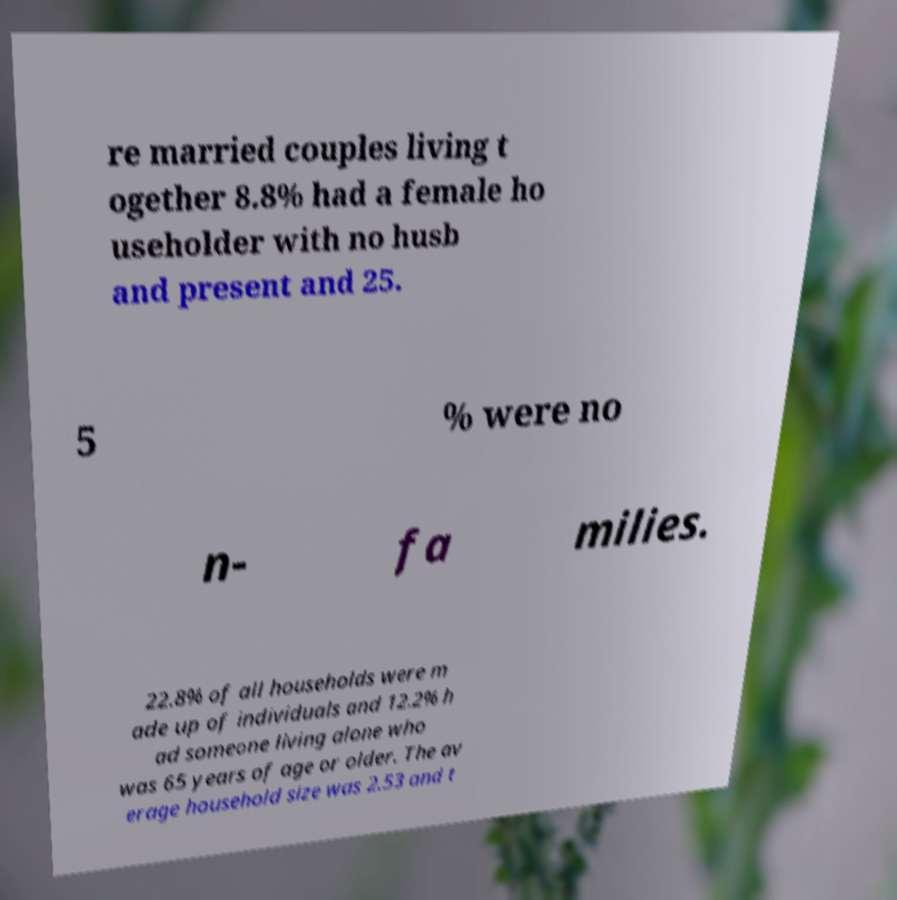There's text embedded in this image that I need extracted. Can you transcribe it verbatim? re married couples living t ogether 8.8% had a female ho useholder with no husb and present and 25. 5 % were no n- fa milies. 22.8% of all households were m ade up of individuals and 12.2% h ad someone living alone who was 65 years of age or older. The av erage household size was 2.53 and t 